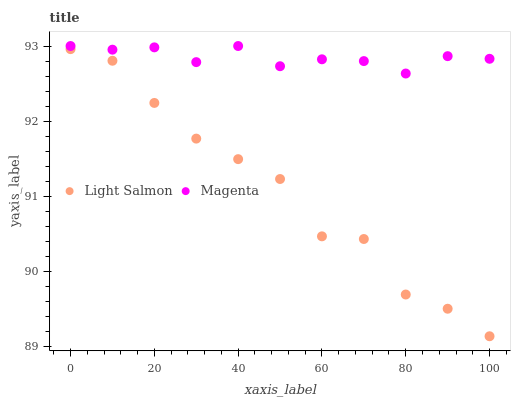Does Light Salmon have the minimum area under the curve?
Answer yes or no. Yes. Does Magenta have the maximum area under the curve?
Answer yes or no. Yes. Does Magenta have the minimum area under the curve?
Answer yes or no. No. Is Magenta the smoothest?
Answer yes or no. Yes. Is Light Salmon the roughest?
Answer yes or no. Yes. Is Magenta the roughest?
Answer yes or no. No. Does Light Salmon have the lowest value?
Answer yes or no. Yes. Does Magenta have the lowest value?
Answer yes or no. No. Does Magenta have the highest value?
Answer yes or no. Yes. Is Light Salmon less than Magenta?
Answer yes or no. Yes. Is Magenta greater than Light Salmon?
Answer yes or no. Yes. Does Light Salmon intersect Magenta?
Answer yes or no. No. 